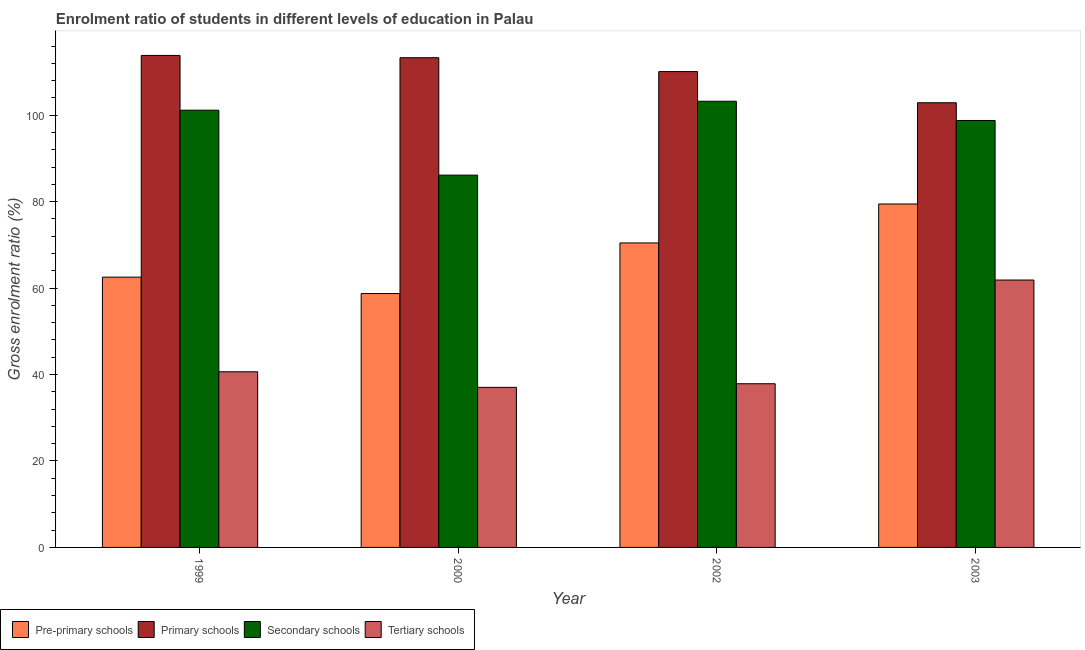Are the number of bars on each tick of the X-axis equal?
Your answer should be compact. Yes. How many bars are there on the 3rd tick from the left?
Keep it short and to the point. 4. How many bars are there on the 1st tick from the right?
Keep it short and to the point. 4. In how many cases, is the number of bars for a given year not equal to the number of legend labels?
Your response must be concise. 0. What is the gross enrolment ratio in pre-primary schools in 2002?
Make the answer very short. 70.45. Across all years, what is the maximum gross enrolment ratio in primary schools?
Provide a short and direct response. 113.83. Across all years, what is the minimum gross enrolment ratio in pre-primary schools?
Provide a succinct answer. 58.74. What is the total gross enrolment ratio in secondary schools in the graph?
Keep it short and to the point. 389.31. What is the difference between the gross enrolment ratio in secondary schools in 1999 and that in 2002?
Keep it short and to the point. -2.07. What is the difference between the gross enrolment ratio in pre-primary schools in 1999 and the gross enrolment ratio in secondary schools in 2000?
Offer a very short reply. 3.8. What is the average gross enrolment ratio in secondary schools per year?
Offer a very short reply. 97.33. What is the ratio of the gross enrolment ratio in pre-primary schools in 1999 to that in 2002?
Your answer should be very brief. 0.89. Is the difference between the gross enrolment ratio in primary schools in 1999 and 2002 greater than the difference between the gross enrolment ratio in pre-primary schools in 1999 and 2002?
Your answer should be very brief. No. What is the difference between the highest and the second highest gross enrolment ratio in secondary schools?
Your answer should be very brief. 2.07. What is the difference between the highest and the lowest gross enrolment ratio in tertiary schools?
Keep it short and to the point. 24.83. What does the 3rd bar from the left in 1999 represents?
Provide a short and direct response. Secondary schools. What does the 4th bar from the right in 2002 represents?
Your answer should be very brief. Pre-primary schools. Are all the bars in the graph horizontal?
Ensure brevity in your answer.  No. How many legend labels are there?
Provide a succinct answer. 4. How are the legend labels stacked?
Ensure brevity in your answer.  Horizontal. What is the title of the graph?
Offer a terse response. Enrolment ratio of students in different levels of education in Palau. What is the label or title of the X-axis?
Offer a terse response. Year. What is the label or title of the Y-axis?
Provide a short and direct response. Gross enrolment ratio (%). What is the Gross enrolment ratio (%) in Pre-primary schools in 1999?
Your answer should be compact. 62.54. What is the Gross enrolment ratio (%) of Primary schools in 1999?
Provide a succinct answer. 113.83. What is the Gross enrolment ratio (%) of Secondary schools in 1999?
Keep it short and to the point. 101.16. What is the Gross enrolment ratio (%) in Tertiary schools in 1999?
Keep it short and to the point. 40.64. What is the Gross enrolment ratio (%) in Pre-primary schools in 2000?
Ensure brevity in your answer.  58.74. What is the Gross enrolment ratio (%) in Primary schools in 2000?
Make the answer very short. 113.3. What is the Gross enrolment ratio (%) in Secondary schools in 2000?
Offer a terse response. 86.14. What is the Gross enrolment ratio (%) of Tertiary schools in 2000?
Offer a terse response. 37.04. What is the Gross enrolment ratio (%) in Pre-primary schools in 2002?
Your answer should be very brief. 70.45. What is the Gross enrolment ratio (%) of Primary schools in 2002?
Give a very brief answer. 110.09. What is the Gross enrolment ratio (%) of Secondary schools in 2002?
Provide a short and direct response. 103.23. What is the Gross enrolment ratio (%) in Tertiary schools in 2002?
Provide a short and direct response. 37.87. What is the Gross enrolment ratio (%) of Pre-primary schools in 2003?
Provide a short and direct response. 79.46. What is the Gross enrolment ratio (%) in Primary schools in 2003?
Your answer should be very brief. 102.88. What is the Gross enrolment ratio (%) of Secondary schools in 2003?
Ensure brevity in your answer.  98.78. What is the Gross enrolment ratio (%) in Tertiary schools in 2003?
Keep it short and to the point. 61.86. Across all years, what is the maximum Gross enrolment ratio (%) of Pre-primary schools?
Provide a short and direct response. 79.46. Across all years, what is the maximum Gross enrolment ratio (%) of Primary schools?
Your response must be concise. 113.83. Across all years, what is the maximum Gross enrolment ratio (%) of Secondary schools?
Keep it short and to the point. 103.23. Across all years, what is the maximum Gross enrolment ratio (%) of Tertiary schools?
Your response must be concise. 61.86. Across all years, what is the minimum Gross enrolment ratio (%) in Pre-primary schools?
Make the answer very short. 58.74. Across all years, what is the minimum Gross enrolment ratio (%) of Primary schools?
Keep it short and to the point. 102.88. Across all years, what is the minimum Gross enrolment ratio (%) of Secondary schools?
Your answer should be very brief. 86.14. Across all years, what is the minimum Gross enrolment ratio (%) of Tertiary schools?
Provide a short and direct response. 37.04. What is the total Gross enrolment ratio (%) in Pre-primary schools in the graph?
Your answer should be compact. 271.18. What is the total Gross enrolment ratio (%) of Primary schools in the graph?
Keep it short and to the point. 440.11. What is the total Gross enrolment ratio (%) of Secondary schools in the graph?
Provide a short and direct response. 389.31. What is the total Gross enrolment ratio (%) in Tertiary schools in the graph?
Offer a terse response. 177.41. What is the difference between the Gross enrolment ratio (%) in Pre-primary schools in 1999 and that in 2000?
Provide a short and direct response. 3.8. What is the difference between the Gross enrolment ratio (%) in Primary schools in 1999 and that in 2000?
Offer a very short reply. 0.53. What is the difference between the Gross enrolment ratio (%) of Secondary schools in 1999 and that in 2000?
Offer a very short reply. 15.03. What is the difference between the Gross enrolment ratio (%) of Tertiary schools in 1999 and that in 2000?
Offer a terse response. 3.6. What is the difference between the Gross enrolment ratio (%) in Pre-primary schools in 1999 and that in 2002?
Ensure brevity in your answer.  -7.91. What is the difference between the Gross enrolment ratio (%) of Primary schools in 1999 and that in 2002?
Provide a succinct answer. 3.74. What is the difference between the Gross enrolment ratio (%) in Secondary schools in 1999 and that in 2002?
Your answer should be compact. -2.07. What is the difference between the Gross enrolment ratio (%) of Tertiary schools in 1999 and that in 2002?
Provide a succinct answer. 2.77. What is the difference between the Gross enrolment ratio (%) of Pre-primary schools in 1999 and that in 2003?
Give a very brief answer. -16.93. What is the difference between the Gross enrolment ratio (%) in Primary schools in 1999 and that in 2003?
Make the answer very short. 10.95. What is the difference between the Gross enrolment ratio (%) in Secondary schools in 1999 and that in 2003?
Make the answer very short. 2.38. What is the difference between the Gross enrolment ratio (%) in Tertiary schools in 1999 and that in 2003?
Give a very brief answer. -21.22. What is the difference between the Gross enrolment ratio (%) of Pre-primary schools in 2000 and that in 2002?
Your response must be concise. -11.71. What is the difference between the Gross enrolment ratio (%) in Primary schools in 2000 and that in 2002?
Offer a terse response. 3.21. What is the difference between the Gross enrolment ratio (%) of Secondary schools in 2000 and that in 2002?
Your answer should be very brief. -17.09. What is the difference between the Gross enrolment ratio (%) in Tertiary schools in 2000 and that in 2002?
Your answer should be very brief. -0.83. What is the difference between the Gross enrolment ratio (%) in Pre-primary schools in 2000 and that in 2003?
Provide a succinct answer. -20.73. What is the difference between the Gross enrolment ratio (%) of Primary schools in 2000 and that in 2003?
Give a very brief answer. 10.42. What is the difference between the Gross enrolment ratio (%) in Secondary schools in 2000 and that in 2003?
Offer a terse response. -12.65. What is the difference between the Gross enrolment ratio (%) of Tertiary schools in 2000 and that in 2003?
Make the answer very short. -24.83. What is the difference between the Gross enrolment ratio (%) of Pre-primary schools in 2002 and that in 2003?
Offer a terse response. -9.01. What is the difference between the Gross enrolment ratio (%) in Primary schools in 2002 and that in 2003?
Your answer should be very brief. 7.21. What is the difference between the Gross enrolment ratio (%) in Secondary schools in 2002 and that in 2003?
Provide a short and direct response. 4.44. What is the difference between the Gross enrolment ratio (%) in Tertiary schools in 2002 and that in 2003?
Your answer should be very brief. -23.99. What is the difference between the Gross enrolment ratio (%) of Pre-primary schools in 1999 and the Gross enrolment ratio (%) of Primary schools in 2000?
Offer a very short reply. -50.77. What is the difference between the Gross enrolment ratio (%) of Pre-primary schools in 1999 and the Gross enrolment ratio (%) of Secondary schools in 2000?
Offer a very short reply. -23.6. What is the difference between the Gross enrolment ratio (%) in Pre-primary schools in 1999 and the Gross enrolment ratio (%) in Tertiary schools in 2000?
Make the answer very short. 25.5. What is the difference between the Gross enrolment ratio (%) in Primary schools in 1999 and the Gross enrolment ratio (%) in Secondary schools in 2000?
Provide a short and direct response. 27.7. What is the difference between the Gross enrolment ratio (%) of Primary schools in 1999 and the Gross enrolment ratio (%) of Tertiary schools in 2000?
Offer a terse response. 76.8. What is the difference between the Gross enrolment ratio (%) of Secondary schools in 1999 and the Gross enrolment ratio (%) of Tertiary schools in 2000?
Give a very brief answer. 64.12. What is the difference between the Gross enrolment ratio (%) of Pre-primary schools in 1999 and the Gross enrolment ratio (%) of Primary schools in 2002?
Your answer should be very brief. -47.56. What is the difference between the Gross enrolment ratio (%) in Pre-primary schools in 1999 and the Gross enrolment ratio (%) in Secondary schools in 2002?
Give a very brief answer. -40.69. What is the difference between the Gross enrolment ratio (%) in Pre-primary schools in 1999 and the Gross enrolment ratio (%) in Tertiary schools in 2002?
Your answer should be compact. 24.66. What is the difference between the Gross enrolment ratio (%) of Primary schools in 1999 and the Gross enrolment ratio (%) of Secondary schools in 2002?
Ensure brevity in your answer.  10.61. What is the difference between the Gross enrolment ratio (%) in Primary schools in 1999 and the Gross enrolment ratio (%) in Tertiary schools in 2002?
Provide a succinct answer. 75.96. What is the difference between the Gross enrolment ratio (%) in Secondary schools in 1999 and the Gross enrolment ratio (%) in Tertiary schools in 2002?
Provide a succinct answer. 63.29. What is the difference between the Gross enrolment ratio (%) in Pre-primary schools in 1999 and the Gross enrolment ratio (%) in Primary schools in 2003?
Make the answer very short. -40.35. What is the difference between the Gross enrolment ratio (%) in Pre-primary schools in 1999 and the Gross enrolment ratio (%) in Secondary schools in 2003?
Your response must be concise. -36.25. What is the difference between the Gross enrolment ratio (%) of Pre-primary schools in 1999 and the Gross enrolment ratio (%) of Tertiary schools in 2003?
Your answer should be very brief. 0.67. What is the difference between the Gross enrolment ratio (%) of Primary schools in 1999 and the Gross enrolment ratio (%) of Secondary schools in 2003?
Offer a very short reply. 15.05. What is the difference between the Gross enrolment ratio (%) of Primary schools in 1999 and the Gross enrolment ratio (%) of Tertiary schools in 2003?
Your answer should be very brief. 51.97. What is the difference between the Gross enrolment ratio (%) in Secondary schools in 1999 and the Gross enrolment ratio (%) in Tertiary schools in 2003?
Provide a short and direct response. 39.3. What is the difference between the Gross enrolment ratio (%) in Pre-primary schools in 2000 and the Gross enrolment ratio (%) in Primary schools in 2002?
Your answer should be compact. -51.36. What is the difference between the Gross enrolment ratio (%) of Pre-primary schools in 2000 and the Gross enrolment ratio (%) of Secondary schools in 2002?
Offer a terse response. -44.49. What is the difference between the Gross enrolment ratio (%) of Pre-primary schools in 2000 and the Gross enrolment ratio (%) of Tertiary schools in 2002?
Make the answer very short. 20.86. What is the difference between the Gross enrolment ratio (%) in Primary schools in 2000 and the Gross enrolment ratio (%) in Secondary schools in 2002?
Your answer should be very brief. 10.07. What is the difference between the Gross enrolment ratio (%) of Primary schools in 2000 and the Gross enrolment ratio (%) of Tertiary schools in 2002?
Offer a very short reply. 75.43. What is the difference between the Gross enrolment ratio (%) in Secondary schools in 2000 and the Gross enrolment ratio (%) in Tertiary schools in 2002?
Give a very brief answer. 48.26. What is the difference between the Gross enrolment ratio (%) in Pre-primary schools in 2000 and the Gross enrolment ratio (%) in Primary schools in 2003?
Provide a succinct answer. -44.15. What is the difference between the Gross enrolment ratio (%) of Pre-primary schools in 2000 and the Gross enrolment ratio (%) of Secondary schools in 2003?
Keep it short and to the point. -40.05. What is the difference between the Gross enrolment ratio (%) of Pre-primary schools in 2000 and the Gross enrolment ratio (%) of Tertiary schools in 2003?
Give a very brief answer. -3.13. What is the difference between the Gross enrolment ratio (%) in Primary schools in 2000 and the Gross enrolment ratio (%) in Secondary schools in 2003?
Provide a short and direct response. 14.52. What is the difference between the Gross enrolment ratio (%) in Primary schools in 2000 and the Gross enrolment ratio (%) in Tertiary schools in 2003?
Offer a terse response. 51.44. What is the difference between the Gross enrolment ratio (%) of Secondary schools in 2000 and the Gross enrolment ratio (%) of Tertiary schools in 2003?
Offer a very short reply. 24.27. What is the difference between the Gross enrolment ratio (%) in Pre-primary schools in 2002 and the Gross enrolment ratio (%) in Primary schools in 2003?
Your answer should be very brief. -32.43. What is the difference between the Gross enrolment ratio (%) in Pre-primary schools in 2002 and the Gross enrolment ratio (%) in Secondary schools in 2003?
Ensure brevity in your answer.  -28.33. What is the difference between the Gross enrolment ratio (%) of Pre-primary schools in 2002 and the Gross enrolment ratio (%) of Tertiary schools in 2003?
Provide a succinct answer. 8.59. What is the difference between the Gross enrolment ratio (%) in Primary schools in 2002 and the Gross enrolment ratio (%) in Secondary schools in 2003?
Provide a succinct answer. 11.31. What is the difference between the Gross enrolment ratio (%) in Primary schools in 2002 and the Gross enrolment ratio (%) in Tertiary schools in 2003?
Your answer should be very brief. 48.23. What is the difference between the Gross enrolment ratio (%) of Secondary schools in 2002 and the Gross enrolment ratio (%) of Tertiary schools in 2003?
Provide a succinct answer. 41.36. What is the average Gross enrolment ratio (%) of Pre-primary schools per year?
Keep it short and to the point. 67.8. What is the average Gross enrolment ratio (%) of Primary schools per year?
Your answer should be compact. 110.03. What is the average Gross enrolment ratio (%) in Secondary schools per year?
Provide a succinct answer. 97.33. What is the average Gross enrolment ratio (%) of Tertiary schools per year?
Ensure brevity in your answer.  44.35. In the year 1999, what is the difference between the Gross enrolment ratio (%) in Pre-primary schools and Gross enrolment ratio (%) in Primary schools?
Your answer should be very brief. -51.3. In the year 1999, what is the difference between the Gross enrolment ratio (%) of Pre-primary schools and Gross enrolment ratio (%) of Secondary schools?
Your answer should be compact. -38.63. In the year 1999, what is the difference between the Gross enrolment ratio (%) in Pre-primary schools and Gross enrolment ratio (%) in Tertiary schools?
Your answer should be very brief. 21.9. In the year 1999, what is the difference between the Gross enrolment ratio (%) of Primary schools and Gross enrolment ratio (%) of Secondary schools?
Ensure brevity in your answer.  12.67. In the year 1999, what is the difference between the Gross enrolment ratio (%) of Primary schools and Gross enrolment ratio (%) of Tertiary schools?
Offer a very short reply. 73.19. In the year 1999, what is the difference between the Gross enrolment ratio (%) in Secondary schools and Gross enrolment ratio (%) in Tertiary schools?
Your answer should be compact. 60.52. In the year 2000, what is the difference between the Gross enrolment ratio (%) in Pre-primary schools and Gross enrolment ratio (%) in Primary schools?
Provide a succinct answer. -54.57. In the year 2000, what is the difference between the Gross enrolment ratio (%) of Pre-primary schools and Gross enrolment ratio (%) of Secondary schools?
Keep it short and to the point. -27.4. In the year 2000, what is the difference between the Gross enrolment ratio (%) in Pre-primary schools and Gross enrolment ratio (%) in Tertiary schools?
Your answer should be compact. 21.7. In the year 2000, what is the difference between the Gross enrolment ratio (%) of Primary schools and Gross enrolment ratio (%) of Secondary schools?
Keep it short and to the point. 27.17. In the year 2000, what is the difference between the Gross enrolment ratio (%) of Primary schools and Gross enrolment ratio (%) of Tertiary schools?
Provide a succinct answer. 76.27. In the year 2000, what is the difference between the Gross enrolment ratio (%) of Secondary schools and Gross enrolment ratio (%) of Tertiary schools?
Your response must be concise. 49.1. In the year 2002, what is the difference between the Gross enrolment ratio (%) in Pre-primary schools and Gross enrolment ratio (%) in Primary schools?
Provide a succinct answer. -39.64. In the year 2002, what is the difference between the Gross enrolment ratio (%) of Pre-primary schools and Gross enrolment ratio (%) of Secondary schools?
Give a very brief answer. -32.78. In the year 2002, what is the difference between the Gross enrolment ratio (%) of Pre-primary schools and Gross enrolment ratio (%) of Tertiary schools?
Keep it short and to the point. 32.58. In the year 2002, what is the difference between the Gross enrolment ratio (%) in Primary schools and Gross enrolment ratio (%) in Secondary schools?
Provide a short and direct response. 6.87. In the year 2002, what is the difference between the Gross enrolment ratio (%) in Primary schools and Gross enrolment ratio (%) in Tertiary schools?
Make the answer very short. 72.22. In the year 2002, what is the difference between the Gross enrolment ratio (%) of Secondary schools and Gross enrolment ratio (%) of Tertiary schools?
Your response must be concise. 65.36. In the year 2003, what is the difference between the Gross enrolment ratio (%) of Pre-primary schools and Gross enrolment ratio (%) of Primary schools?
Provide a succinct answer. -23.42. In the year 2003, what is the difference between the Gross enrolment ratio (%) in Pre-primary schools and Gross enrolment ratio (%) in Secondary schools?
Your response must be concise. -19.32. In the year 2003, what is the difference between the Gross enrolment ratio (%) of Pre-primary schools and Gross enrolment ratio (%) of Tertiary schools?
Ensure brevity in your answer.  17.6. In the year 2003, what is the difference between the Gross enrolment ratio (%) of Primary schools and Gross enrolment ratio (%) of Secondary schools?
Ensure brevity in your answer.  4.1. In the year 2003, what is the difference between the Gross enrolment ratio (%) of Primary schools and Gross enrolment ratio (%) of Tertiary schools?
Ensure brevity in your answer.  41.02. In the year 2003, what is the difference between the Gross enrolment ratio (%) in Secondary schools and Gross enrolment ratio (%) in Tertiary schools?
Your response must be concise. 36.92. What is the ratio of the Gross enrolment ratio (%) in Pre-primary schools in 1999 to that in 2000?
Make the answer very short. 1.06. What is the ratio of the Gross enrolment ratio (%) in Primary schools in 1999 to that in 2000?
Your response must be concise. 1. What is the ratio of the Gross enrolment ratio (%) in Secondary schools in 1999 to that in 2000?
Provide a succinct answer. 1.17. What is the ratio of the Gross enrolment ratio (%) in Tertiary schools in 1999 to that in 2000?
Keep it short and to the point. 1.1. What is the ratio of the Gross enrolment ratio (%) in Pre-primary schools in 1999 to that in 2002?
Your answer should be very brief. 0.89. What is the ratio of the Gross enrolment ratio (%) of Primary schools in 1999 to that in 2002?
Keep it short and to the point. 1.03. What is the ratio of the Gross enrolment ratio (%) in Secondary schools in 1999 to that in 2002?
Provide a succinct answer. 0.98. What is the ratio of the Gross enrolment ratio (%) in Tertiary schools in 1999 to that in 2002?
Provide a short and direct response. 1.07. What is the ratio of the Gross enrolment ratio (%) in Pre-primary schools in 1999 to that in 2003?
Offer a terse response. 0.79. What is the ratio of the Gross enrolment ratio (%) of Primary schools in 1999 to that in 2003?
Make the answer very short. 1.11. What is the ratio of the Gross enrolment ratio (%) in Secondary schools in 1999 to that in 2003?
Your answer should be very brief. 1.02. What is the ratio of the Gross enrolment ratio (%) of Tertiary schools in 1999 to that in 2003?
Provide a succinct answer. 0.66. What is the ratio of the Gross enrolment ratio (%) in Pre-primary schools in 2000 to that in 2002?
Offer a terse response. 0.83. What is the ratio of the Gross enrolment ratio (%) of Primary schools in 2000 to that in 2002?
Ensure brevity in your answer.  1.03. What is the ratio of the Gross enrolment ratio (%) in Secondary schools in 2000 to that in 2002?
Provide a succinct answer. 0.83. What is the ratio of the Gross enrolment ratio (%) of Pre-primary schools in 2000 to that in 2003?
Offer a very short reply. 0.74. What is the ratio of the Gross enrolment ratio (%) of Primary schools in 2000 to that in 2003?
Keep it short and to the point. 1.1. What is the ratio of the Gross enrolment ratio (%) of Secondary schools in 2000 to that in 2003?
Ensure brevity in your answer.  0.87. What is the ratio of the Gross enrolment ratio (%) of Tertiary schools in 2000 to that in 2003?
Provide a succinct answer. 0.6. What is the ratio of the Gross enrolment ratio (%) in Pre-primary schools in 2002 to that in 2003?
Give a very brief answer. 0.89. What is the ratio of the Gross enrolment ratio (%) in Primary schools in 2002 to that in 2003?
Provide a short and direct response. 1.07. What is the ratio of the Gross enrolment ratio (%) of Secondary schools in 2002 to that in 2003?
Offer a terse response. 1.04. What is the ratio of the Gross enrolment ratio (%) of Tertiary schools in 2002 to that in 2003?
Your answer should be very brief. 0.61. What is the difference between the highest and the second highest Gross enrolment ratio (%) in Pre-primary schools?
Give a very brief answer. 9.01. What is the difference between the highest and the second highest Gross enrolment ratio (%) of Primary schools?
Offer a terse response. 0.53. What is the difference between the highest and the second highest Gross enrolment ratio (%) in Secondary schools?
Your answer should be very brief. 2.07. What is the difference between the highest and the second highest Gross enrolment ratio (%) of Tertiary schools?
Make the answer very short. 21.22. What is the difference between the highest and the lowest Gross enrolment ratio (%) in Pre-primary schools?
Your response must be concise. 20.73. What is the difference between the highest and the lowest Gross enrolment ratio (%) of Primary schools?
Your answer should be compact. 10.95. What is the difference between the highest and the lowest Gross enrolment ratio (%) of Secondary schools?
Provide a succinct answer. 17.09. What is the difference between the highest and the lowest Gross enrolment ratio (%) in Tertiary schools?
Your answer should be very brief. 24.83. 